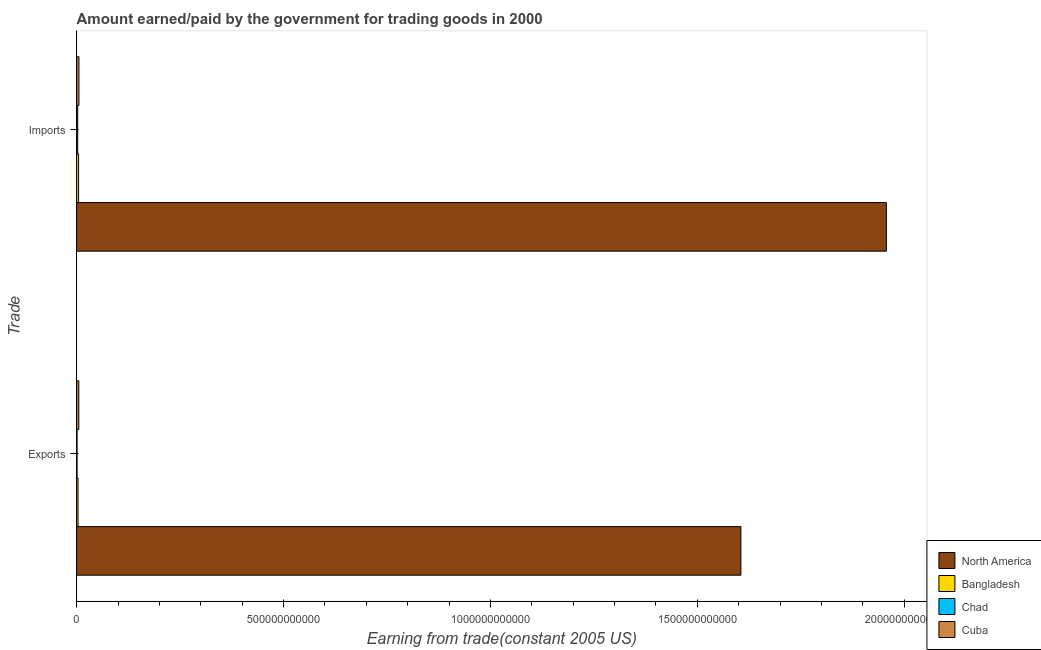How many different coloured bars are there?
Ensure brevity in your answer.  4. Are the number of bars per tick equal to the number of legend labels?
Your response must be concise. Yes. How many bars are there on the 2nd tick from the top?
Provide a short and direct response. 4. What is the label of the 2nd group of bars from the top?
Ensure brevity in your answer.  Exports. What is the amount paid for imports in Cuba?
Your answer should be compact. 5.50e+09. Across all countries, what is the maximum amount earned from exports?
Your response must be concise. 1.61e+12. Across all countries, what is the minimum amount earned from exports?
Your response must be concise. 9.21e+08. In which country was the amount earned from exports maximum?
Offer a very short reply. North America. In which country was the amount earned from exports minimum?
Your response must be concise. Chad. What is the total amount paid for imports in the graph?
Provide a succinct answer. 1.97e+12. What is the difference between the amount paid for imports in Chad and that in Bangladesh?
Offer a very short reply. -2.19e+09. What is the difference between the amount paid for imports in Chad and the amount earned from exports in Cuba?
Ensure brevity in your answer.  -2.72e+09. What is the average amount earned from exports per country?
Provide a succinct answer. 4.04e+11. What is the difference between the amount earned from exports and amount paid for imports in Chad?
Make the answer very short. -1.56e+09. What is the ratio of the amount paid for imports in Bangladesh to that in North America?
Your answer should be compact. 0. Is the amount earned from exports in Bangladesh less than that in Cuba?
Provide a short and direct response. Yes. In how many countries, is the amount earned from exports greater than the average amount earned from exports taken over all countries?
Ensure brevity in your answer.  1. What does the 2nd bar from the top in Exports represents?
Make the answer very short. Chad. How many bars are there?
Your answer should be compact. 8. Are all the bars in the graph horizontal?
Your answer should be very brief. Yes. What is the difference between two consecutive major ticks on the X-axis?
Your answer should be compact. 5.00e+11. Where does the legend appear in the graph?
Provide a succinct answer. Bottom right. How many legend labels are there?
Keep it short and to the point. 4. What is the title of the graph?
Your response must be concise. Amount earned/paid by the government for trading goods in 2000. What is the label or title of the X-axis?
Make the answer very short. Earning from trade(constant 2005 US). What is the label or title of the Y-axis?
Give a very brief answer. Trade. What is the Earning from trade(constant 2005 US) in North America in Exports?
Give a very brief answer. 1.61e+12. What is the Earning from trade(constant 2005 US) in Bangladesh in Exports?
Give a very brief answer. 3.34e+09. What is the Earning from trade(constant 2005 US) in Chad in Exports?
Your response must be concise. 9.21e+08. What is the Earning from trade(constant 2005 US) of Cuba in Exports?
Offer a terse response. 5.20e+09. What is the Earning from trade(constant 2005 US) in North America in Imports?
Your response must be concise. 1.96e+12. What is the Earning from trade(constant 2005 US) in Bangladesh in Imports?
Keep it short and to the point. 4.67e+09. What is the Earning from trade(constant 2005 US) of Chad in Imports?
Offer a terse response. 2.48e+09. What is the Earning from trade(constant 2005 US) in Cuba in Imports?
Your response must be concise. 5.50e+09. Across all Trade, what is the maximum Earning from trade(constant 2005 US) in North America?
Ensure brevity in your answer.  1.96e+12. Across all Trade, what is the maximum Earning from trade(constant 2005 US) of Bangladesh?
Your answer should be very brief. 4.67e+09. Across all Trade, what is the maximum Earning from trade(constant 2005 US) of Chad?
Make the answer very short. 2.48e+09. Across all Trade, what is the maximum Earning from trade(constant 2005 US) in Cuba?
Your answer should be compact. 5.50e+09. Across all Trade, what is the minimum Earning from trade(constant 2005 US) in North America?
Offer a very short reply. 1.61e+12. Across all Trade, what is the minimum Earning from trade(constant 2005 US) in Bangladesh?
Ensure brevity in your answer.  3.34e+09. Across all Trade, what is the minimum Earning from trade(constant 2005 US) of Chad?
Offer a terse response. 9.21e+08. Across all Trade, what is the minimum Earning from trade(constant 2005 US) of Cuba?
Your answer should be compact. 5.20e+09. What is the total Earning from trade(constant 2005 US) in North America in the graph?
Keep it short and to the point. 3.56e+12. What is the total Earning from trade(constant 2005 US) in Bangladesh in the graph?
Your response must be concise. 8.01e+09. What is the total Earning from trade(constant 2005 US) of Chad in the graph?
Ensure brevity in your answer.  3.40e+09. What is the total Earning from trade(constant 2005 US) in Cuba in the graph?
Your answer should be compact. 1.07e+1. What is the difference between the Earning from trade(constant 2005 US) in North America in Exports and that in Imports?
Make the answer very short. -3.52e+11. What is the difference between the Earning from trade(constant 2005 US) in Bangladesh in Exports and that in Imports?
Your answer should be compact. -1.33e+09. What is the difference between the Earning from trade(constant 2005 US) of Chad in Exports and that in Imports?
Your answer should be very brief. -1.56e+09. What is the difference between the Earning from trade(constant 2005 US) of Cuba in Exports and that in Imports?
Offer a terse response. -3.00e+08. What is the difference between the Earning from trade(constant 2005 US) of North America in Exports and the Earning from trade(constant 2005 US) of Bangladesh in Imports?
Keep it short and to the point. 1.60e+12. What is the difference between the Earning from trade(constant 2005 US) of North America in Exports and the Earning from trade(constant 2005 US) of Chad in Imports?
Give a very brief answer. 1.60e+12. What is the difference between the Earning from trade(constant 2005 US) of North America in Exports and the Earning from trade(constant 2005 US) of Cuba in Imports?
Make the answer very short. 1.60e+12. What is the difference between the Earning from trade(constant 2005 US) of Bangladesh in Exports and the Earning from trade(constant 2005 US) of Chad in Imports?
Give a very brief answer. 8.59e+08. What is the difference between the Earning from trade(constant 2005 US) in Bangladesh in Exports and the Earning from trade(constant 2005 US) in Cuba in Imports?
Ensure brevity in your answer.  -2.16e+09. What is the difference between the Earning from trade(constant 2005 US) of Chad in Exports and the Earning from trade(constant 2005 US) of Cuba in Imports?
Give a very brief answer. -4.58e+09. What is the average Earning from trade(constant 2005 US) of North America per Trade?
Your answer should be compact. 1.78e+12. What is the average Earning from trade(constant 2005 US) in Bangladesh per Trade?
Your answer should be compact. 4.01e+09. What is the average Earning from trade(constant 2005 US) in Chad per Trade?
Your answer should be compact. 1.70e+09. What is the average Earning from trade(constant 2005 US) in Cuba per Trade?
Give a very brief answer. 5.35e+09. What is the difference between the Earning from trade(constant 2005 US) of North America and Earning from trade(constant 2005 US) of Bangladesh in Exports?
Ensure brevity in your answer.  1.60e+12. What is the difference between the Earning from trade(constant 2005 US) of North America and Earning from trade(constant 2005 US) of Chad in Exports?
Your answer should be very brief. 1.60e+12. What is the difference between the Earning from trade(constant 2005 US) in North America and Earning from trade(constant 2005 US) in Cuba in Exports?
Your response must be concise. 1.60e+12. What is the difference between the Earning from trade(constant 2005 US) of Bangladesh and Earning from trade(constant 2005 US) of Chad in Exports?
Make the answer very short. 2.42e+09. What is the difference between the Earning from trade(constant 2005 US) in Bangladesh and Earning from trade(constant 2005 US) in Cuba in Exports?
Offer a very short reply. -1.86e+09. What is the difference between the Earning from trade(constant 2005 US) in Chad and Earning from trade(constant 2005 US) in Cuba in Exports?
Your response must be concise. -4.28e+09. What is the difference between the Earning from trade(constant 2005 US) in North America and Earning from trade(constant 2005 US) in Bangladesh in Imports?
Provide a succinct answer. 1.95e+12. What is the difference between the Earning from trade(constant 2005 US) of North America and Earning from trade(constant 2005 US) of Chad in Imports?
Ensure brevity in your answer.  1.95e+12. What is the difference between the Earning from trade(constant 2005 US) in North America and Earning from trade(constant 2005 US) in Cuba in Imports?
Make the answer very short. 1.95e+12. What is the difference between the Earning from trade(constant 2005 US) in Bangladesh and Earning from trade(constant 2005 US) in Chad in Imports?
Provide a short and direct response. 2.19e+09. What is the difference between the Earning from trade(constant 2005 US) of Bangladesh and Earning from trade(constant 2005 US) of Cuba in Imports?
Offer a very short reply. -8.31e+08. What is the difference between the Earning from trade(constant 2005 US) of Chad and Earning from trade(constant 2005 US) of Cuba in Imports?
Provide a succinct answer. -3.02e+09. What is the ratio of the Earning from trade(constant 2005 US) in North America in Exports to that in Imports?
Provide a succinct answer. 0.82. What is the ratio of the Earning from trade(constant 2005 US) of Bangladesh in Exports to that in Imports?
Provide a succinct answer. 0.71. What is the ratio of the Earning from trade(constant 2005 US) in Chad in Exports to that in Imports?
Offer a very short reply. 0.37. What is the ratio of the Earning from trade(constant 2005 US) in Cuba in Exports to that in Imports?
Make the answer very short. 0.95. What is the difference between the highest and the second highest Earning from trade(constant 2005 US) of North America?
Your response must be concise. 3.52e+11. What is the difference between the highest and the second highest Earning from trade(constant 2005 US) in Bangladesh?
Give a very brief answer. 1.33e+09. What is the difference between the highest and the second highest Earning from trade(constant 2005 US) in Chad?
Keep it short and to the point. 1.56e+09. What is the difference between the highest and the second highest Earning from trade(constant 2005 US) of Cuba?
Provide a short and direct response. 3.00e+08. What is the difference between the highest and the lowest Earning from trade(constant 2005 US) of North America?
Give a very brief answer. 3.52e+11. What is the difference between the highest and the lowest Earning from trade(constant 2005 US) in Bangladesh?
Provide a succinct answer. 1.33e+09. What is the difference between the highest and the lowest Earning from trade(constant 2005 US) of Chad?
Your answer should be very brief. 1.56e+09. What is the difference between the highest and the lowest Earning from trade(constant 2005 US) of Cuba?
Your response must be concise. 3.00e+08. 